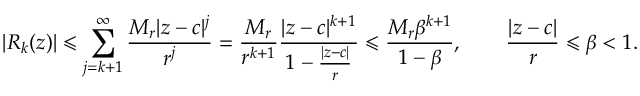Convert formula to latex. <formula><loc_0><loc_0><loc_500><loc_500>| R _ { k } ( z ) | \leqslant \sum _ { j = k + 1 } ^ { \infty } { \frac { M _ { r } | z - c | ^ { j } } { r ^ { j } } } = { \frac { M _ { r } } { r ^ { k + 1 } } } { \frac { | z - c | ^ { k + 1 } } { 1 - { \frac { | z - c | } { r } } } } \leqslant { \frac { M _ { r } \beta ^ { k + 1 } } { 1 - \beta } } , \quad { \frac { | z - c | } { r } } \leqslant \beta < 1 .</formula> 